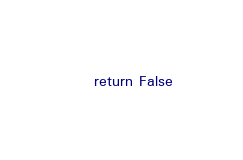Convert code to text. <code><loc_0><loc_0><loc_500><loc_500><_Python_>
	return False</code> 